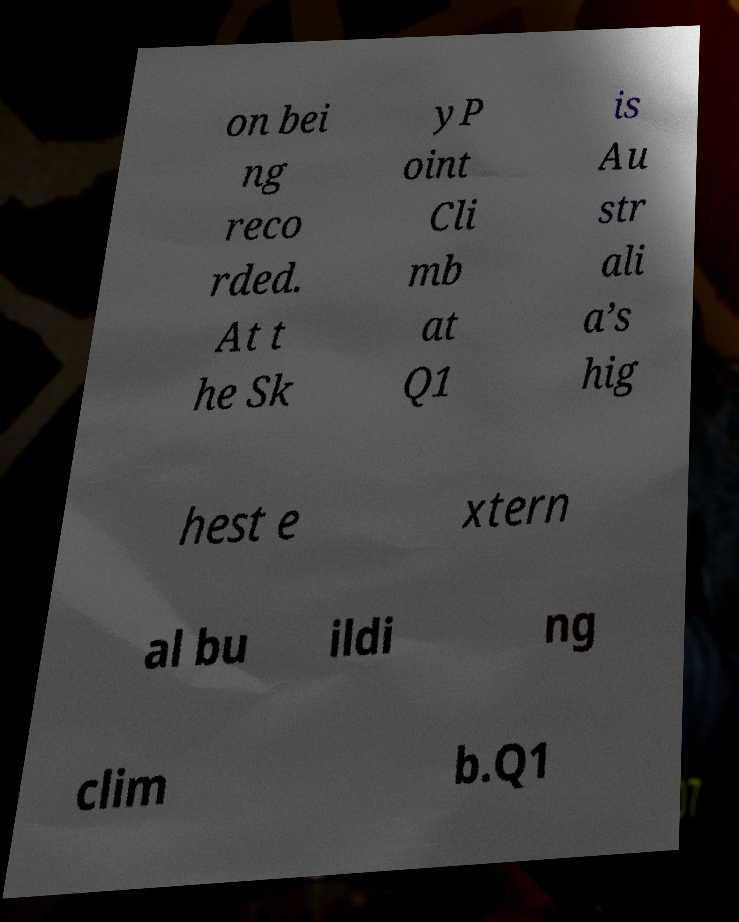I need the written content from this picture converted into text. Can you do that? on bei ng reco rded. At t he Sk yP oint Cli mb at Q1 is Au str ali a’s hig hest e xtern al bu ildi ng clim b.Q1 